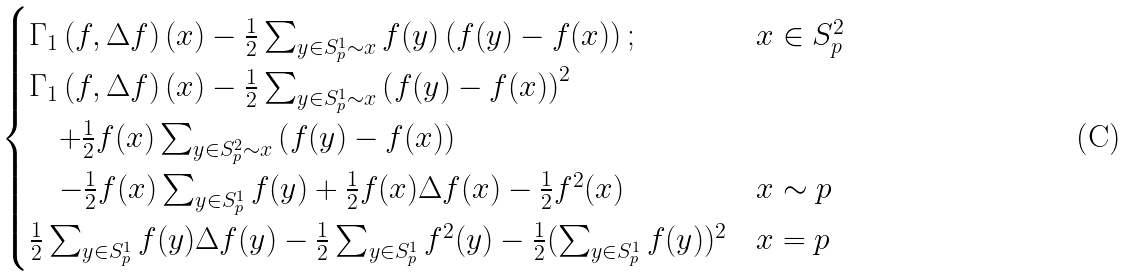Convert formula to latex. <formula><loc_0><loc_0><loc_500><loc_500>\begin{cases} \Gamma _ { 1 } \left ( f , \Delta f \right ) ( x ) - \frac { 1 } { 2 } \sum _ { y \in S ^ { 1 } _ { p } \sim x } f ( y ) \left ( f ( y ) - f ( x ) \right ) ; & x \in S ^ { 2 } _ { p } \\ \Gamma _ { 1 } \left ( f , \Delta f \right ) ( x ) - \frac { 1 } { 2 } \sum _ { y \in S ^ { 1 } _ { p } \sim x } \left ( f ( y ) - f ( x ) \right ) ^ { 2 } \\ \quad + \frac { 1 } { 2 } f ( x ) \sum _ { y \in S ^ { 2 } _ { p } \sim x } \left ( f ( y ) - f ( x ) \right ) \\ \quad - \frac { 1 } { 2 } f ( x ) \sum _ { y \in S ^ { 1 } _ { p } } f ( y ) + \frac { 1 } { 2 } f ( x ) \Delta f ( x ) - \frac { 1 } { 2 } f ^ { 2 } ( x ) & x \sim p \\ \frac { 1 } { 2 } \sum _ { y \in S ^ { 1 } _ { p } } f ( y ) \Delta f ( y ) - \frac { 1 } { 2 } \sum _ { y \in S ^ { 1 } _ { p } } f ^ { 2 } ( y ) - \frac { 1 } { 2 } ( \sum _ { y \in S ^ { 1 } _ { p } } f ( y ) ) ^ { 2 } & x = p \end{cases}</formula> 